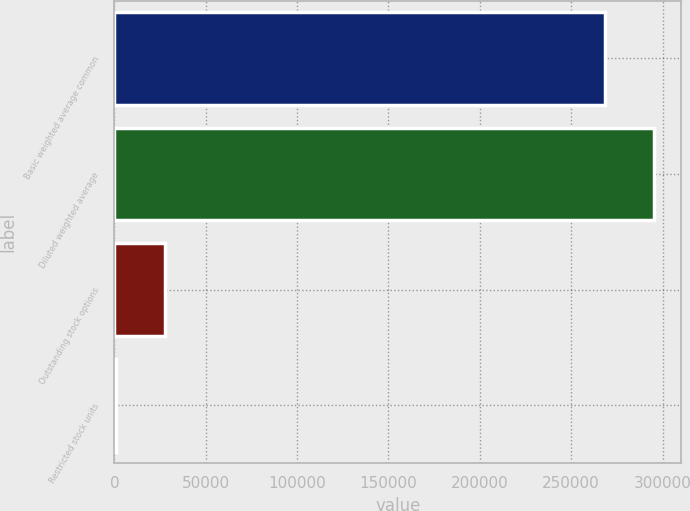Convert chart. <chart><loc_0><loc_0><loc_500><loc_500><bar_chart><fcel>Basic weighted average common<fcel>Diluted weighted average<fcel>Outstanding stock options<fcel>Restricted stock units<nl><fcel>268704<fcel>295464<fcel>27868.5<fcel>1109<nl></chart> 